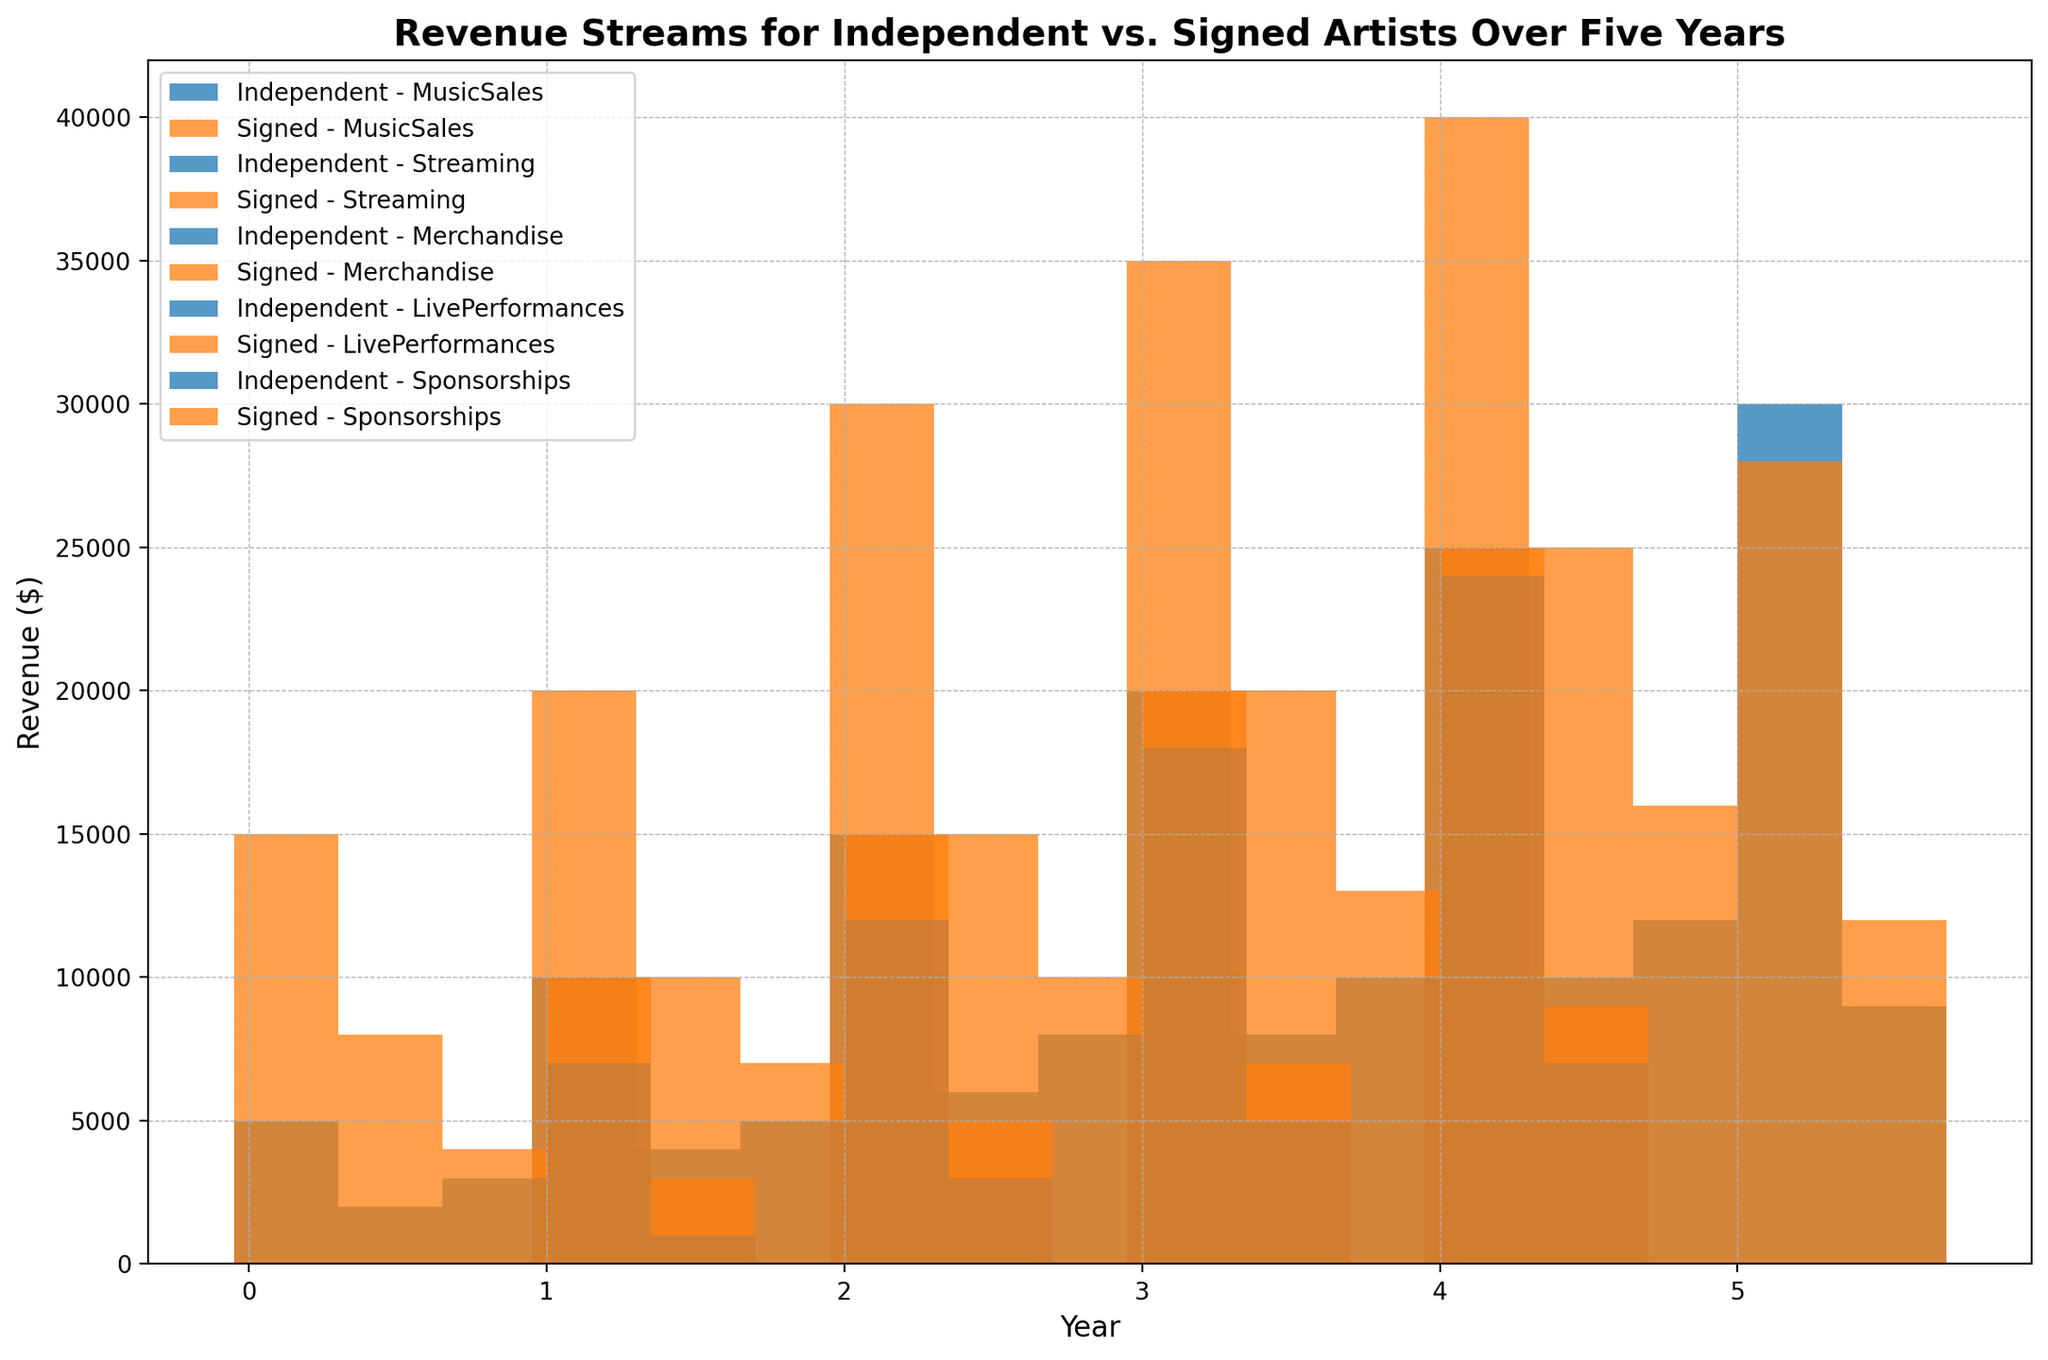How does the revenue from live performances for independent artists in year 1 compare to year 5? Compare the height of the bars representing live performances for independent artists in year 1 and year 5. The bar in year 5 is significantly higher than the bar in year 1.
Answer: Revenue from live performances for independent artists in year 5 is higher than in year 1 Which revenue stream shows the greatest difference between independent and signed artists in year 3? Look at the bars for each revenue stream in year 3 and calculate the difference between the signed and independent artist’s bars. Music sales have the greatest difference.
Answer: Music sales If you sum up the revenue from streaming for independent artists over the five years, what do you get? Add up the heights of the bars representing streaming for independent artists for each year: 2000 + 4000 + 6000 + 8000 + 10000.
Answer: 30000 What is the total revenue from sponsorships in year 4 for both independent and signed artists? Add the heights of the two bars (independent and signed) representing sponsorships in year 4 together.
Answer: 16000 Which year had the highest revenue from merchandise for signed artists? Look at the height of the bars representing merchandise for signed artists across all years to find the highest one. Year 5 has the tallest bar for signed artists' merchandise.
Answer: Year 5 Do signed artists earn more than independent artists from live performances in year 5? Compare the height of the bars representing live performances for signed and independent artists in year 5. The bar for independent artists is slightly higher.
Answer: No, independent artists earn more How has the revenue from music sales for signed artists changed from year 2 to year 4? Compare the height of the bars for signed artists' music sales in year 2 and year 4. The height increases from year 2 to year 4.
Answer: It increased What is the average revenue from live performances for independent artists over the five years? Add the revenue from live performances for independent artists each year (7000 + 12000 + 18000 + 24000 + 30000), then divide by 5.
Answer: 18200 Which revenue stream had the lowest revenue for independent artists in year 2? Look at the heights of the bars in year 2 for independent artists and identify the shortest one.
Answer: Sponsorships How does the total revenue from merchandise compare between independent and signed artists over five years? Calculate the total for each: Independent (3000 + 5000 + 8000 + 10000 + 12000), Signed (4000 + 7000 + 10000 + 13000 + 16000). Compare the two totals.
Answer: Signed artists earn more 